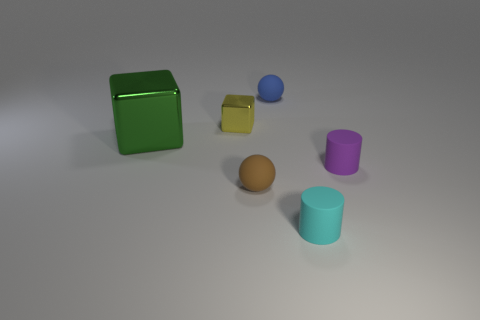Add 2 small cyan matte cylinders. How many objects exist? 8 Subtract all blocks. How many objects are left? 4 Subtract 0 gray balls. How many objects are left? 6 Subtract all gray blocks. Subtract all blue spheres. How many blocks are left? 2 Subtract all big brown cylinders. Subtract all tiny spheres. How many objects are left? 4 Add 3 yellow things. How many yellow things are left? 4 Add 5 gray blocks. How many gray blocks exist? 5 